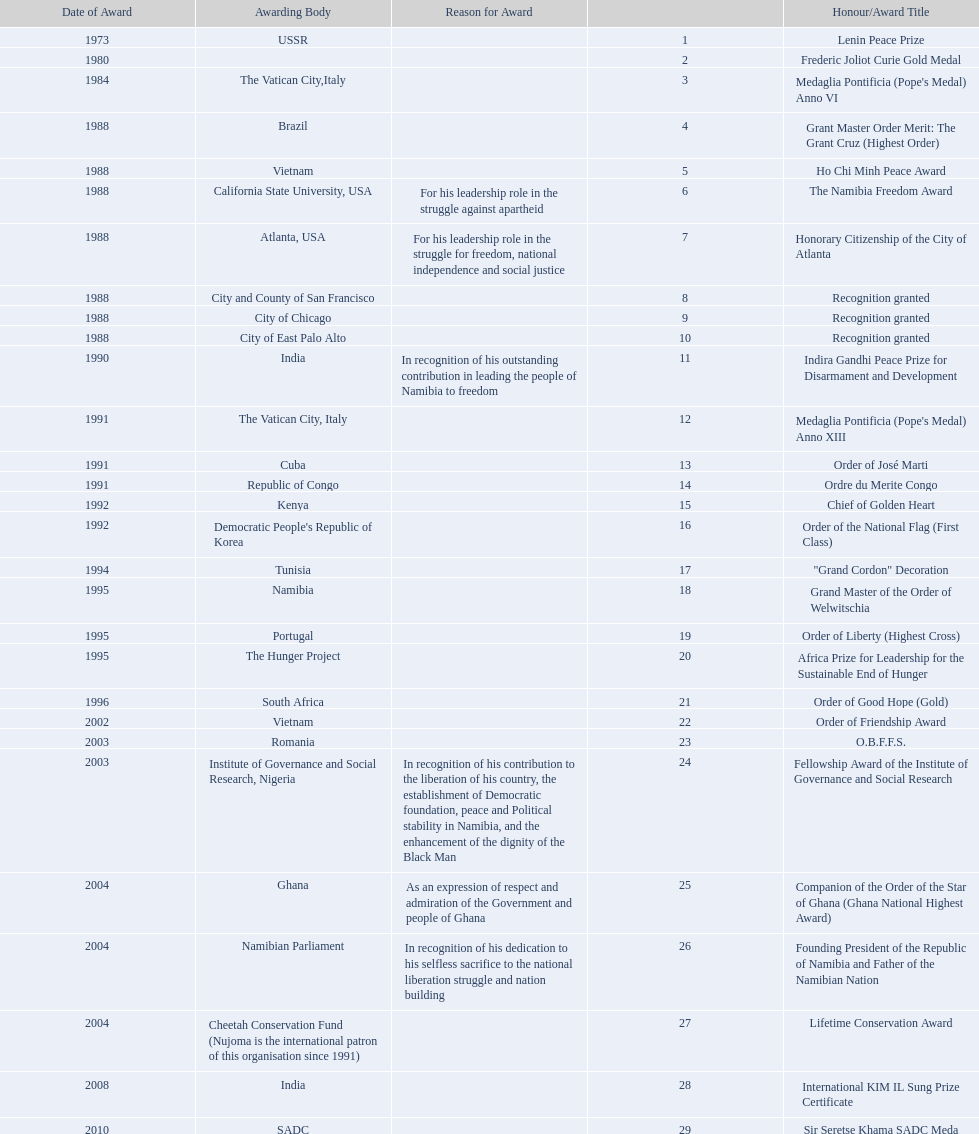Which awarding bodies have recognized sam nujoma? USSR, , The Vatican City,Italy, Brazil, Vietnam, California State University, USA, Atlanta, USA, City and County of San Francisco, City of Chicago, City of East Palo Alto, India, The Vatican City, Italy, Cuba, Republic of Congo, Kenya, Democratic People's Republic of Korea, Tunisia, Namibia, Portugal, The Hunger Project, South Africa, Vietnam, Romania, Institute of Governance and Social Research, Nigeria, Ghana, Namibian Parliament, Cheetah Conservation Fund (Nujoma is the international patron of this organisation since 1991), India, SADC. And what was the title of each award or honour? Lenin Peace Prize, Frederic Joliot Curie Gold Medal, Medaglia Pontificia (Pope's Medal) Anno VI, Grant Master Order Merit: The Grant Cruz (Highest Order), Ho Chi Minh Peace Award, The Namibia Freedom Award, Honorary Citizenship of the City of Atlanta, Recognition granted, Recognition granted, Recognition granted, Indira Gandhi Peace Prize for Disarmament and Development, Medaglia Pontificia (Pope's Medal) Anno XIII, Order of José Marti, Ordre du Merite Congo, Chief of Golden Heart, Order of the National Flag (First Class), "Grand Cordon" Decoration, Grand Master of the Order of Welwitschia, Order of Liberty (Highest Cross), Africa Prize for Leadership for the Sustainable End of Hunger, Order of Good Hope (Gold), Order of Friendship Award, O.B.F.F.S., Fellowship Award of the Institute of Governance and Social Research, Companion of the Order of the Star of Ghana (Ghana National Highest Award), Founding President of the Republic of Namibia and Father of the Namibian Nation, Lifetime Conservation Award, International KIM IL Sung Prize Certificate, Sir Seretse Khama SADC Meda. Of those, which nation awarded him the o.b.f.f.s.? Romania. 